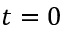Convert formula to latex. <formula><loc_0><loc_0><loc_500><loc_500>t = 0</formula> 